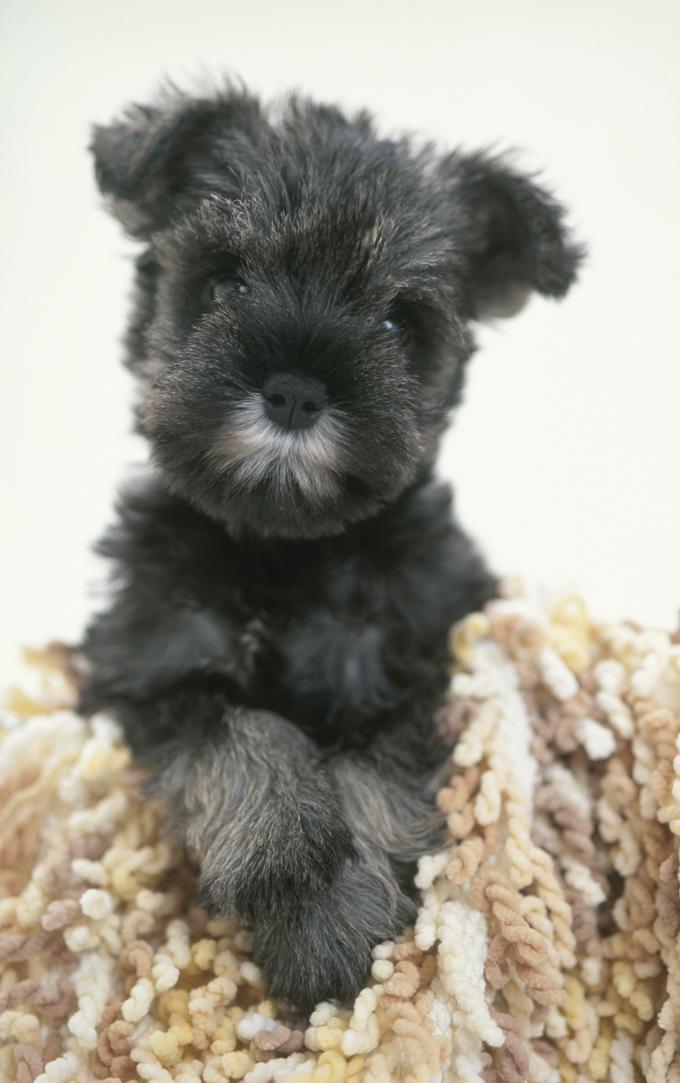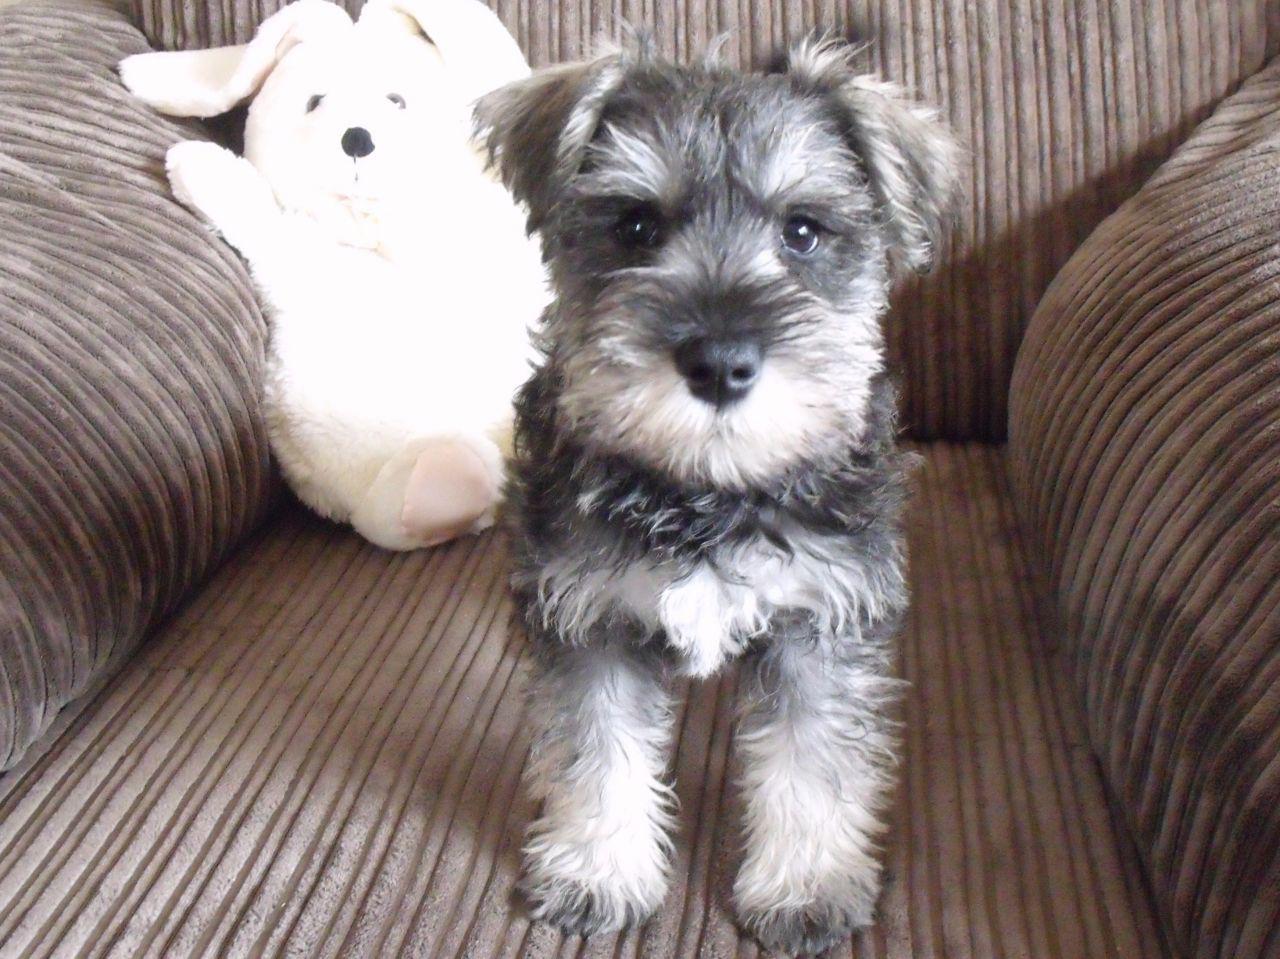The first image is the image on the left, the second image is the image on the right. Evaluate the accuracy of this statement regarding the images: "An image shows one schnauzer dog on a piece of upholstered furniture, next to a soft object.". Is it true? Answer yes or no. Yes. The first image is the image on the left, the second image is the image on the right. Evaluate the accuracy of this statement regarding the images: "The dog in the image on the left is wearing a collar.". Is it true? Answer yes or no. No. 